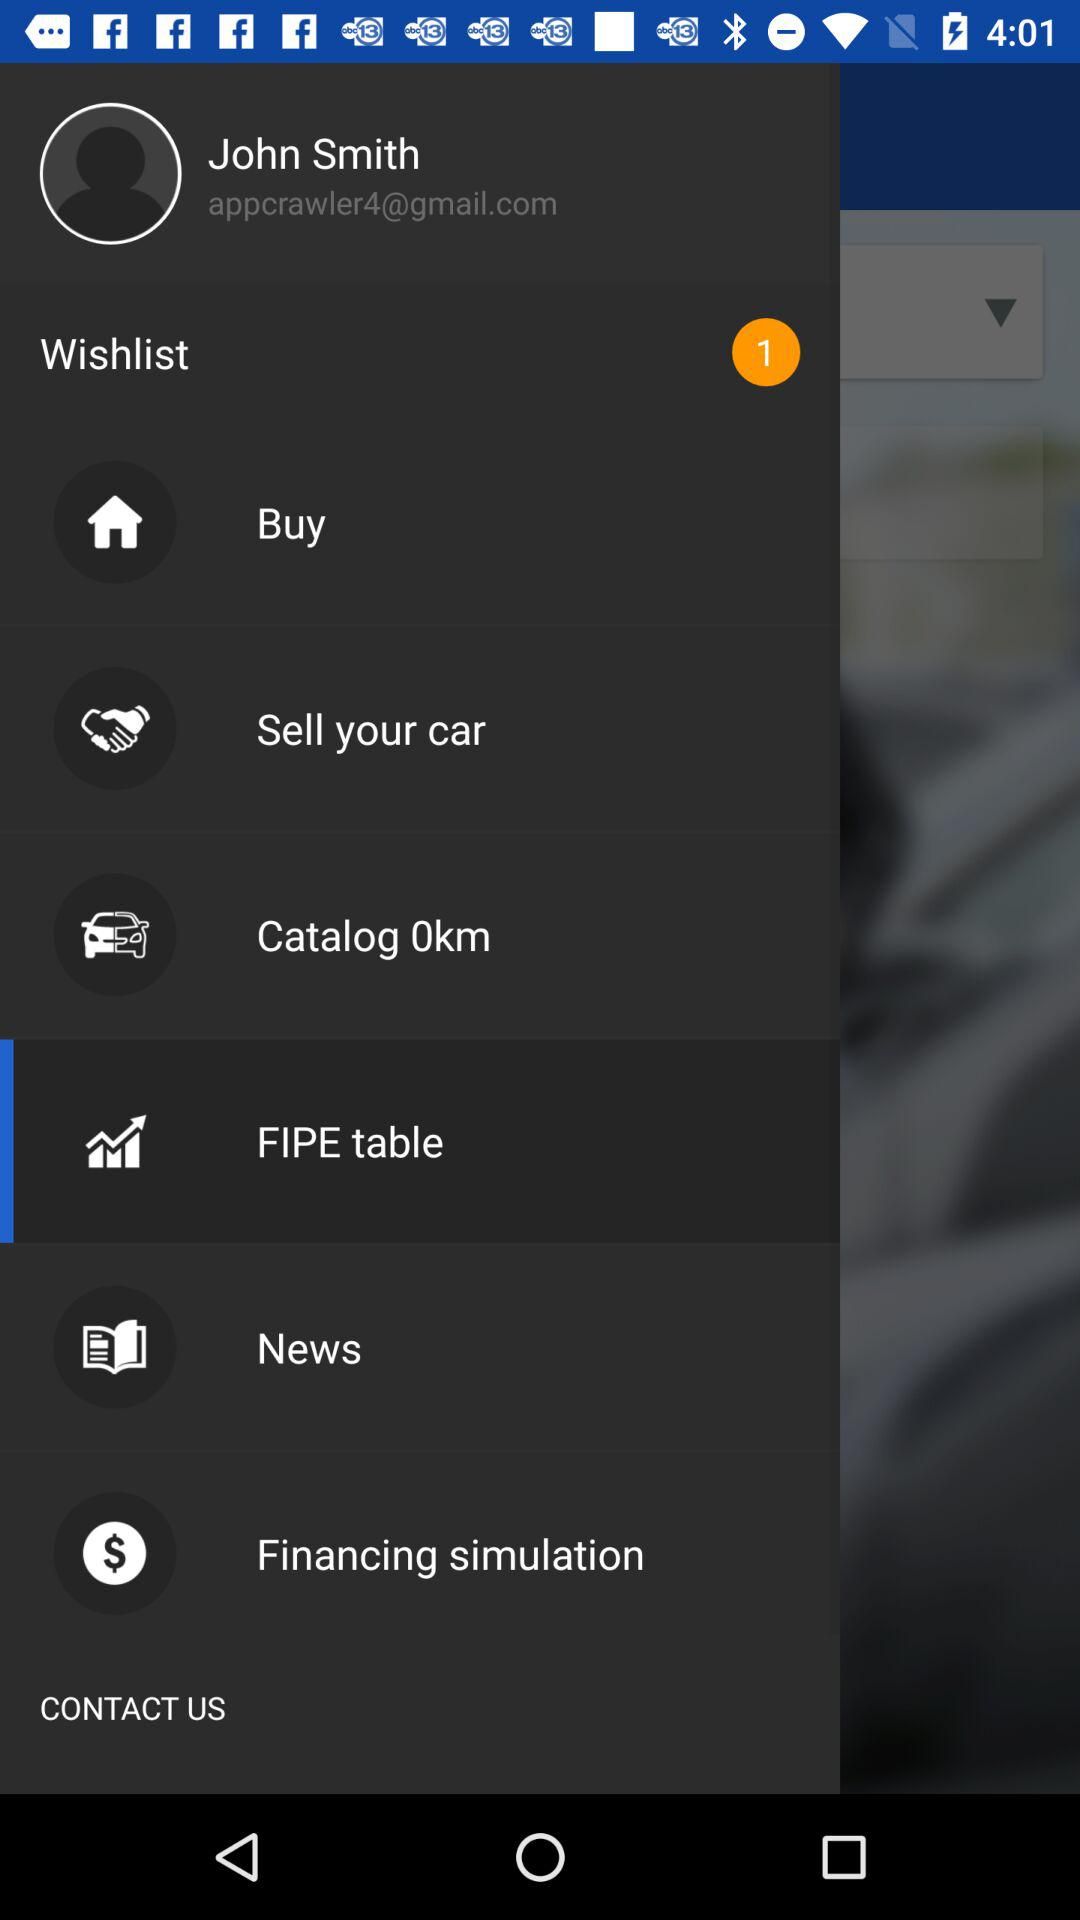How many unread counts are in wishlist? There is only 1 count. 